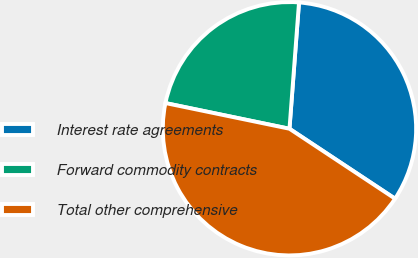Convert chart to OTSL. <chart><loc_0><loc_0><loc_500><loc_500><pie_chart><fcel>Interest rate agreements<fcel>Forward commodity contracts<fcel>Total other comprehensive<nl><fcel>33.11%<fcel>22.95%<fcel>43.94%<nl></chart> 